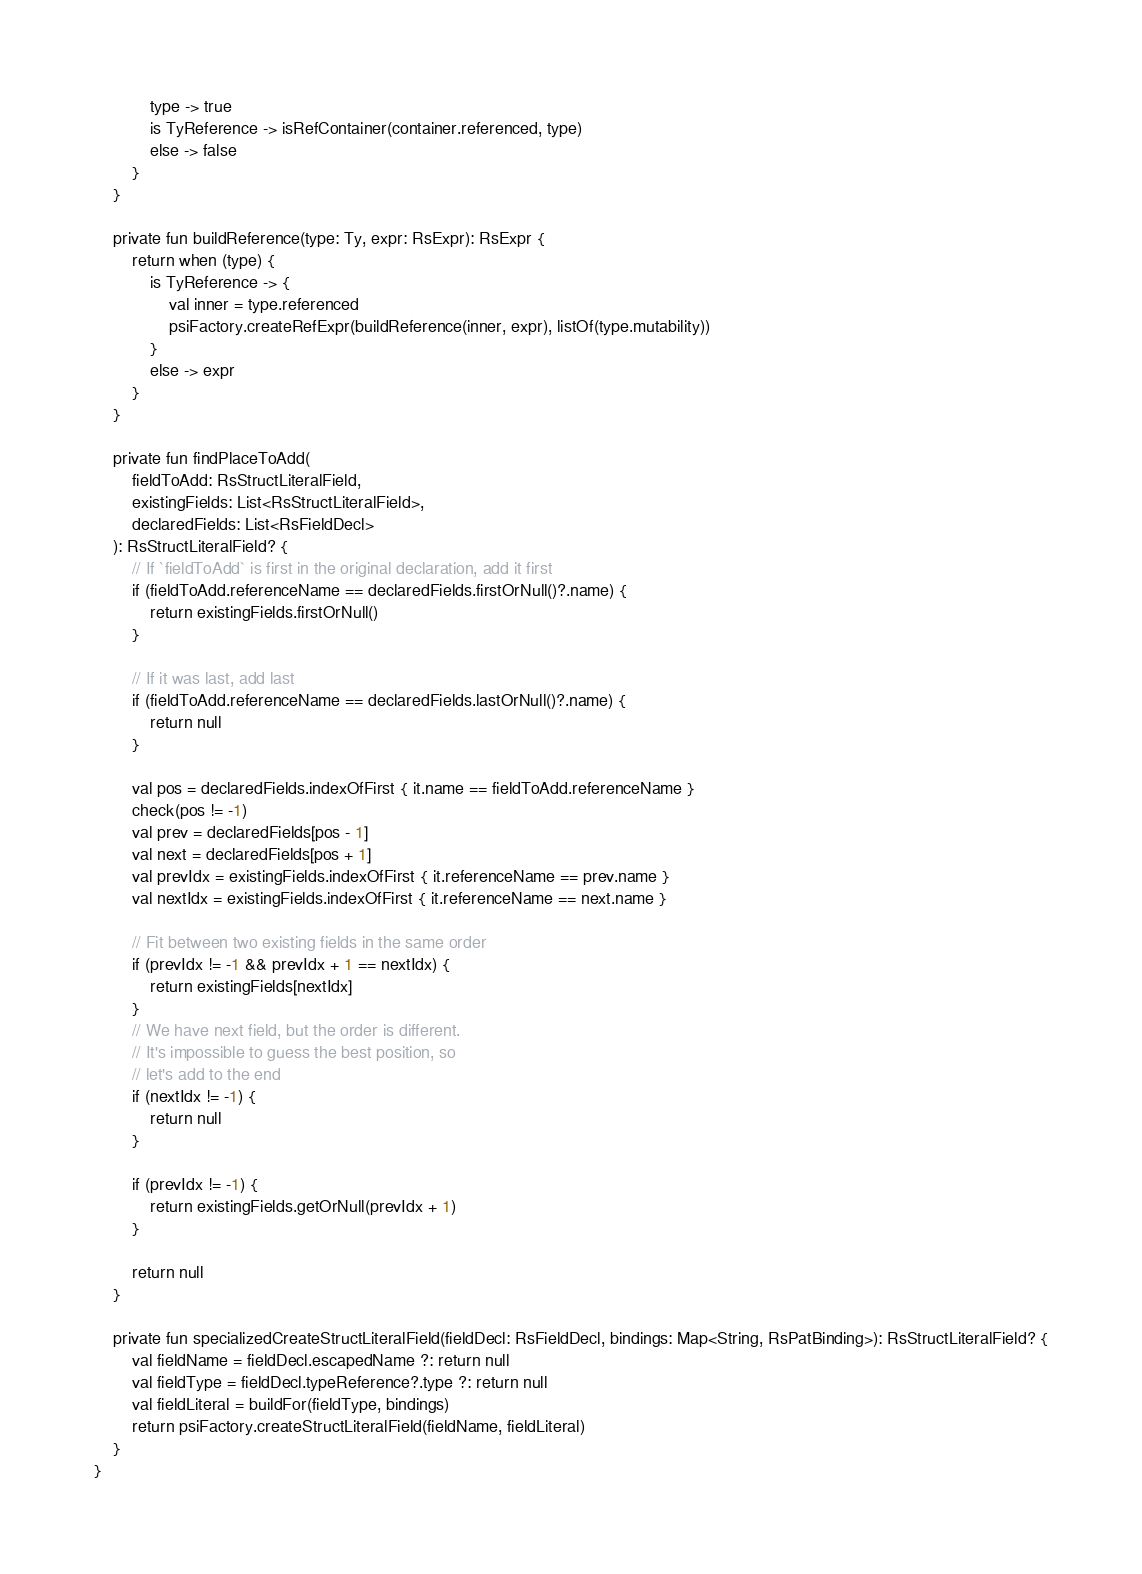Convert code to text. <code><loc_0><loc_0><loc_500><loc_500><_Kotlin_>            type -> true
            is TyReference -> isRefContainer(container.referenced, type)
            else -> false
        }
    }

    private fun buildReference(type: Ty, expr: RsExpr): RsExpr {
        return when (type) {
            is TyReference -> {
                val inner = type.referenced
                psiFactory.createRefExpr(buildReference(inner, expr), listOf(type.mutability))
            }
            else -> expr
        }
    }

    private fun findPlaceToAdd(
        fieldToAdd: RsStructLiteralField,
        existingFields: List<RsStructLiteralField>,
        declaredFields: List<RsFieldDecl>
    ): RsStructLiteralField? {
        // If `fieldToAdd` is first in the original declaration, add it first
        if (fieldToAdd.referenceName == declaredFields.firstOrNull()?.name) {
            return existingFields.firstOrNull()
        }

        // If it was last, add last
        if (fieldToAdd.referenceName == declaredFields.lastOrNull()?.name) {
            return null
        }

        val pos = declaredFields.indexOfFirst { it.name == fieldToAdd.referenceName }
        check(pos != -1)
        val prev = declaredFields[pos - 1]
        val next = declaredFields[pos + 1]
        val prevIdx = existingFields.indexOfFirst { it.referenceName == prev.name }
        val nextIdx = existingFields.indexOfFirst { it.referenceName == next.name }

        // Fit between two existing fields in the same order
        if (prevIdx != -1 && prevIdx + 1 == nextIdx) {
            return existingFields[nextIdx]
        }
        // We have next field, but the order is different.
        // It's impossible to guess the best position, so
        // let's add to the end
        if (nextIdx != -1) {
            return null
        }

        if (prevIdx != -1) {
            return existingFields.getOrNull(prevIdx + 1)
        }

        return null
    }

    private fun specializedCreateStructLiteralField(fieldDecl: RsFieldDecl, bindings: Map<String, RsPatBinding>): RsStructLiteralField? {
        val fieldName = fieldDecl.escapedName ?: return null
        val fieldType = fieldDecl.typeReference?.type ?: return null
        val fieldLiteral = buildFor(fieldType, bindings)
        return psiFactory.createStructLiteralField(fieldName, fieldLiteral)
    }
}
</code> 